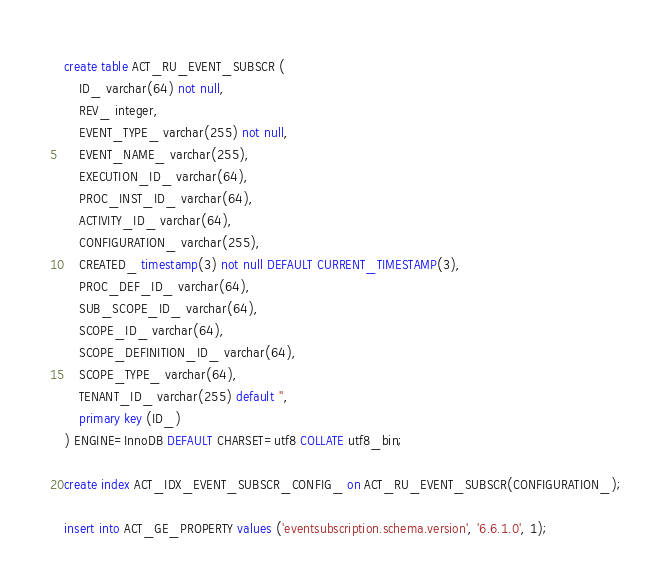Convert code to text. <code><loc_0><loc_0><loc_500><loc_500><_SQL_>create table ACT_RU_EVENT_SUBSCR (
    ID_ varchar(64) not null,
    REV_ integer,
    EVENT_TYPE_ varchar(255) not null,
    EVENT_NAME_ varchar(255),
    EXECUTION_ID_ varchar(64),
    PROC_INST_ID_ varchar(64),
    ACTIVITY_ID_ varchar(64),
    CONFIGURATION_ varchar(255),
    CREATED_ timestamp(3) not null DEFAULT CURRENT_TIMESTAMP(3),
    PROC_DEF_ID_ varchar(64),
    SUB_SCOPE_ID_ varchar(64),
    SCOPE_ID_ varchar(64),
    SCOPE_DEFINITION_ID_ varchar(64),
    SCOPE_TYPE_ varchar(64),
    TENANT_ID_ varchar(255) default '',
    primary key (ID_)
) ENGINE=InnoDB DEFAULT CHARSET=utf8 COLLATE utf8_bin;

create index ACT_IDX_EVENT_SUBSCR_CONFIG_ on ACT_RU_EVENT_SUBSCR(CONFIGURATION_);

insert into ACT_GE_PROPERTY values ('eventsubscription.schema.version', '6.6.1.0', 1);</code> 